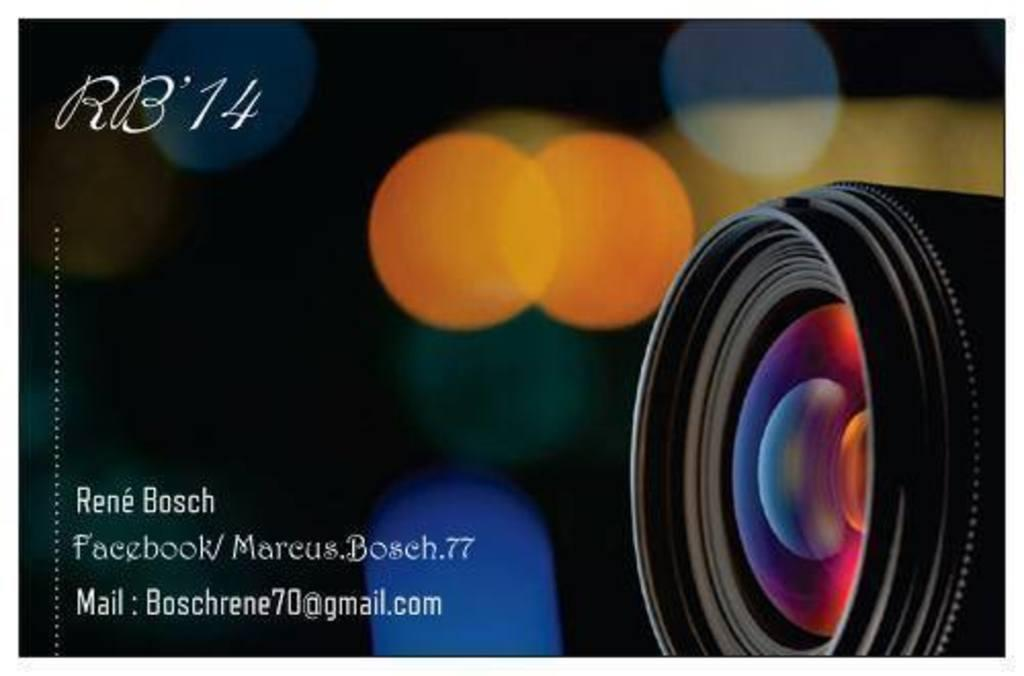What can be found on the left side of the image? There is text on the left side of the image. What is located on the right side of the image? There is a camera on the right side of the image. What can be seen in the background of the image? There are lights visible in the background of the image. What type of animal can be seen interacting with the camera in the image? There are no animals present in the image; it features text on the left side and a camera on the right side. What kind of plants are growing near the text in the image? There are no plants visible in the image; it only shows text on the left side and a camera on the right side. 